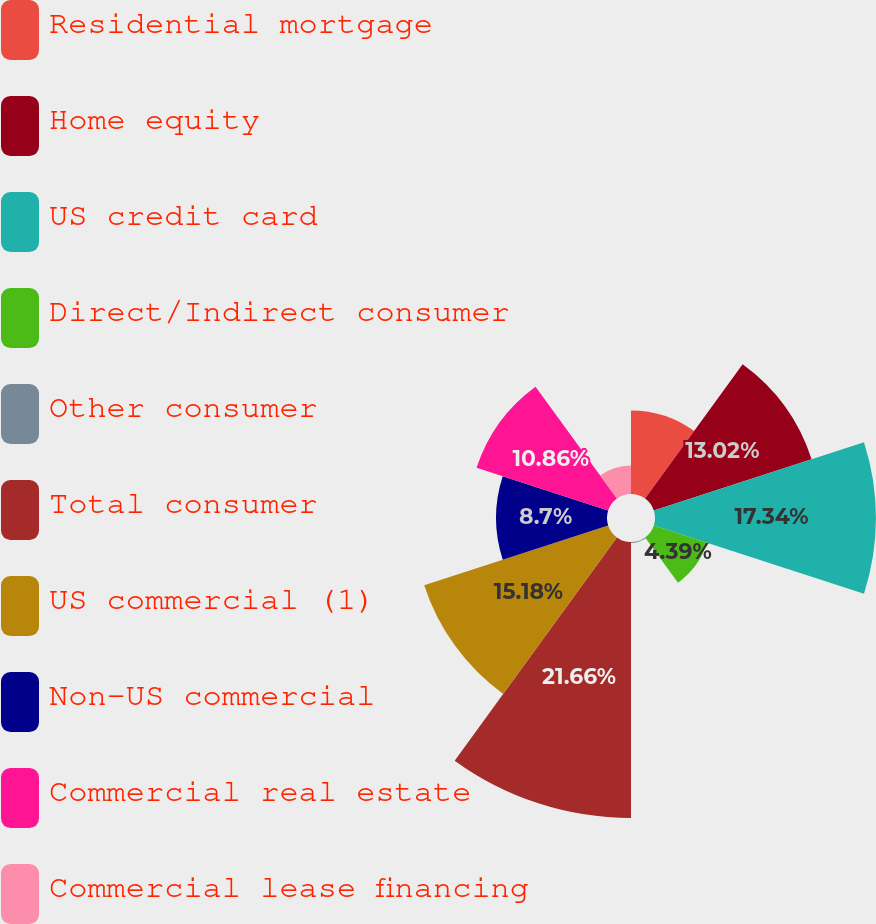<chart> <loc_0><loc_0><loc_500><loc_500><pie_chart><fcel>Residential mortgage<fcel>Home equity<fcel>US credit card<fcel>Direct/Indirect consumer<fcel>Other consumer<fcel>Total consumer<fcel>US commercial (1)<fcel>Non-US commercial<fcel>Commercial real estate<fcel>Commercial lease financing<nl><fcel>6.55%<fcel>13.02%<fcel>17.34%<fcel>4.39%<fcel>0.07%<fcel>21.66%<fcel>15.18%<fcel>8.7%<fcel>10.86%<fcel>2.23%<nl></chart> 